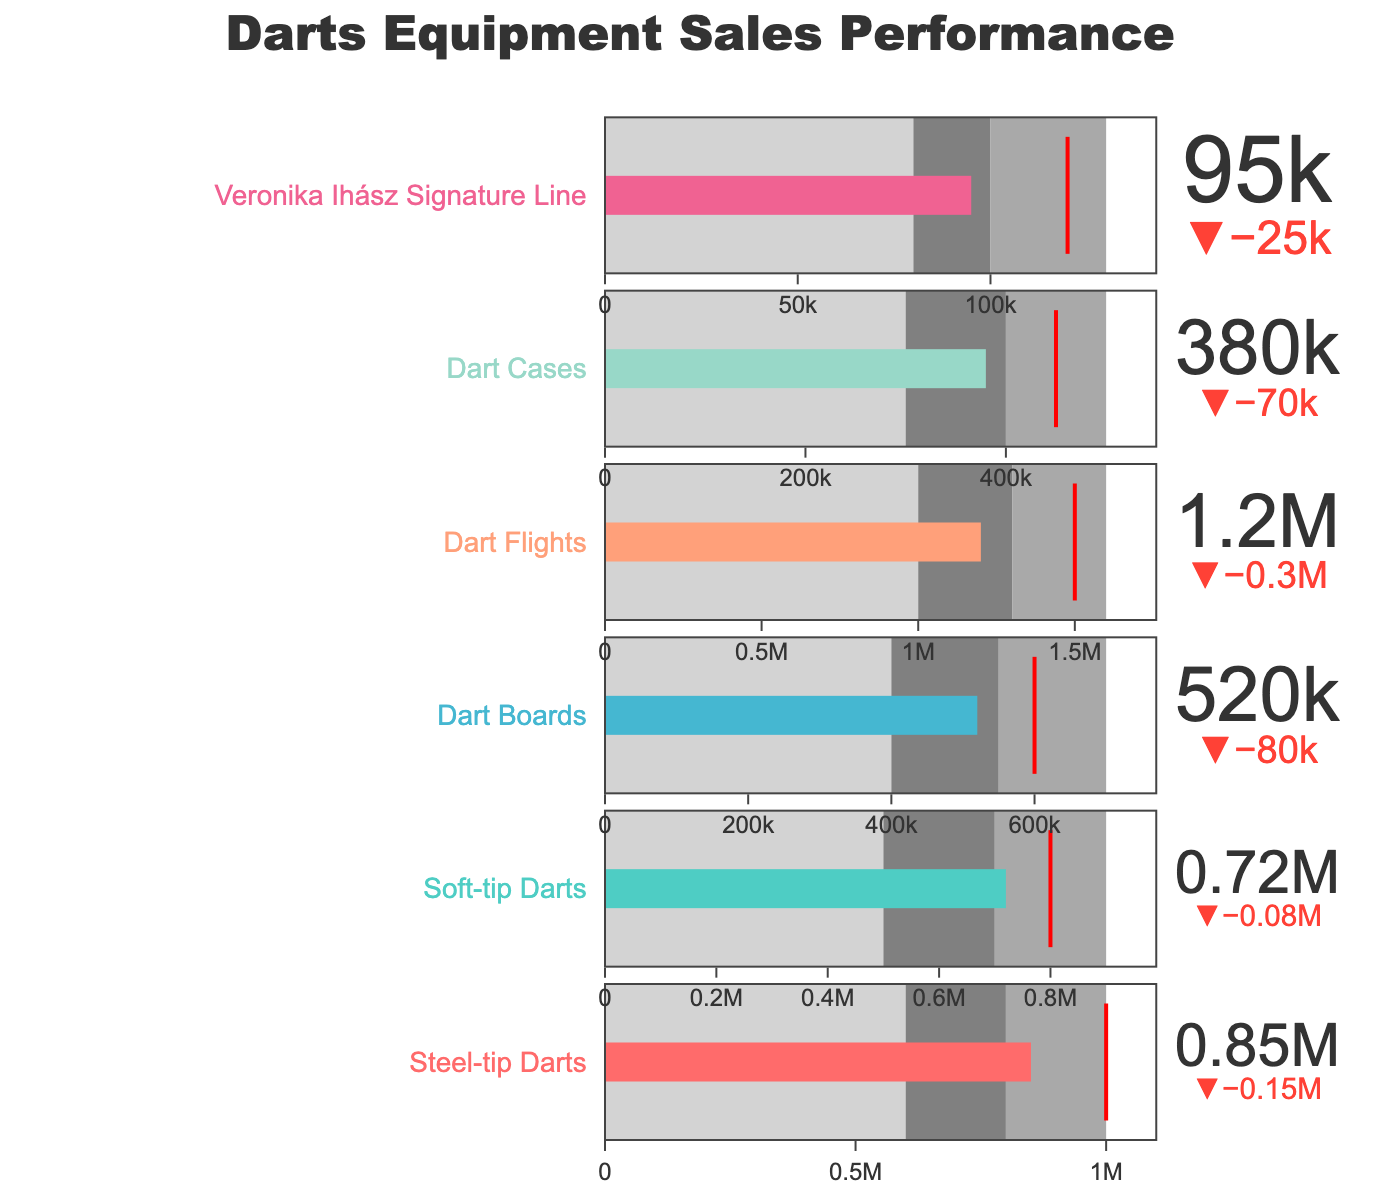What color represents the "Soft-tip Darts" category? The Bullet Chart uses different colors for each category. From the data provided, "Soft-tip Darts" corresponds to the second category which is colored in '#4ECDC4', translating to a shade of teal.
Answer: teal What is the title of the Bullet Chart? The title of the Bullet Chart is centrally placed on the figure. It reads "Darts Equipment Sales Performance".
Answer: Darts Equipment Sales Performance What is the actual sales figure for "Veronika Ihász Signature Line"? The actual sales figures for each category are displayed prominently within each Bullet Chart. For "Veronika Ihász Signature Line," the actual sales figure is 95,000.
Answer: 95,000 Which category has the smallest actual sales figure? By comparing the actual sales figures displayed for each category in the Bullet Chart, we see that "Veronika Ihász Signature Line" has the smallest figure at 95,000.
Answer: Veronika Ihász Signature Line Which category exceeded its target? To identify categories that exceeded their targets, we compare actual sales figures against target figures. None of the categories exceed their target value.
Answer: None How far below the target is "Steel-tip Darts" in absolute terms? The actual sales for "Steel-tip Darts" is 850,000, and the target is 1,000,000. The difference is 1,000,000 - 850,000 = 150,000.
Answer: 150,000 Which category achieved the closest target to their actual sales? To find the closest target, we look for the smallest absolute difference between actual sales and target for each category. "Soft-tip Darts" has actual sales of 720,000 and a target of 800,000, resulting in a difference of 80,000, the smallest among all categories.
Answer: Soft-tip Darts What is the average of the actual sales figures for all categories? Summing the actual sales figures for all categories: 850,000 + 720,000 + 520,000 + 1,200,000 + 380,000 + 95,000 = 3,765,000. Then, dividing by the number of categories (6), we get 3,765,000 / 6 = 627,500.
Answer: 627,500 Which category has the widest range between Range1 and Range3? To find the widest range, subtract Range1 from Range3 for each category and compare: 
- Steel-tip Darts: 1,000,000 - 600,000 = 400,000 
- Soft-tip Darts: 900,000 - 500,000 = 400,000 
- Dart Boards: 700,000 - 400,000 = 300,000 
- Dart Flights: 1,600,000 - 1,000,000 = 600,000 
- Dart Cases: 500,000 - 300,000 = 200,000 
- Veronika Ihász Signature Line: 130,000 - 80,000 = 50,000 
"Dart Flights" has the widest range.
Answer: Dart Flights 